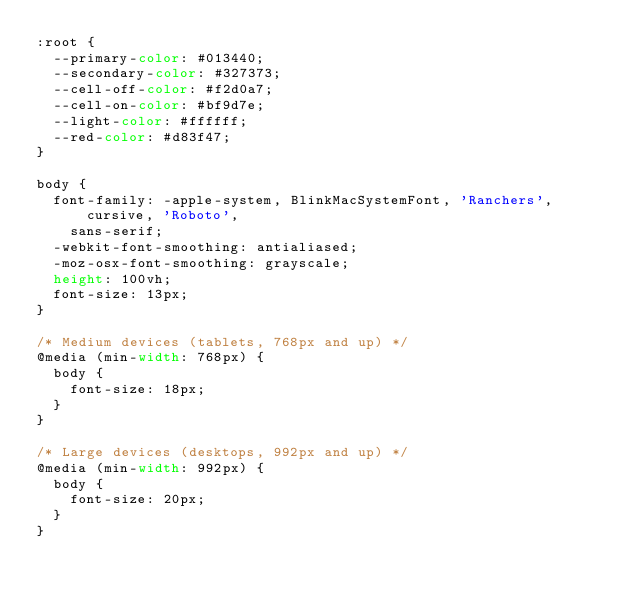Convert code to text. <code><loc_0><loc_0><loc_500><loc_500><_CSS_>:root {
  --primary-color: #013440;
  --secondary-color: #327373;
  --cell-off-color: #f2d0a7;
  --cell-on-color: #bf9d7e;
  --light-color: #ffffff;
  --red-color: #d83f47;
}

body {
  font-family: -apple-system, BlinkMacSystemFont, 'Ranchers', cursive, 'Roboto',
    sans-serif;
  -webkit-font-smoothing: antialiased;
  -moz-osx-font-smoothing: grayscale;
  height: 100vh;
  font-size: 13px;
}

/* Medium devices (tablets, 768px and up) */
@media (min-width: 768px) {
  body {
    font-size: 18px;
  }
}

/* Large devices (desktops, 992px and up) */
@media (min-width: 992px) {
  body {
    font-size: 20px;
  }
}
</code> 